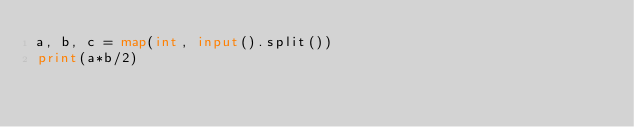Convert code to text. <code><loc_0><loc_0><loc_500><loc_500><_Python_>a, b, c = map(int, input().split())
print(a*b/2)</code> 